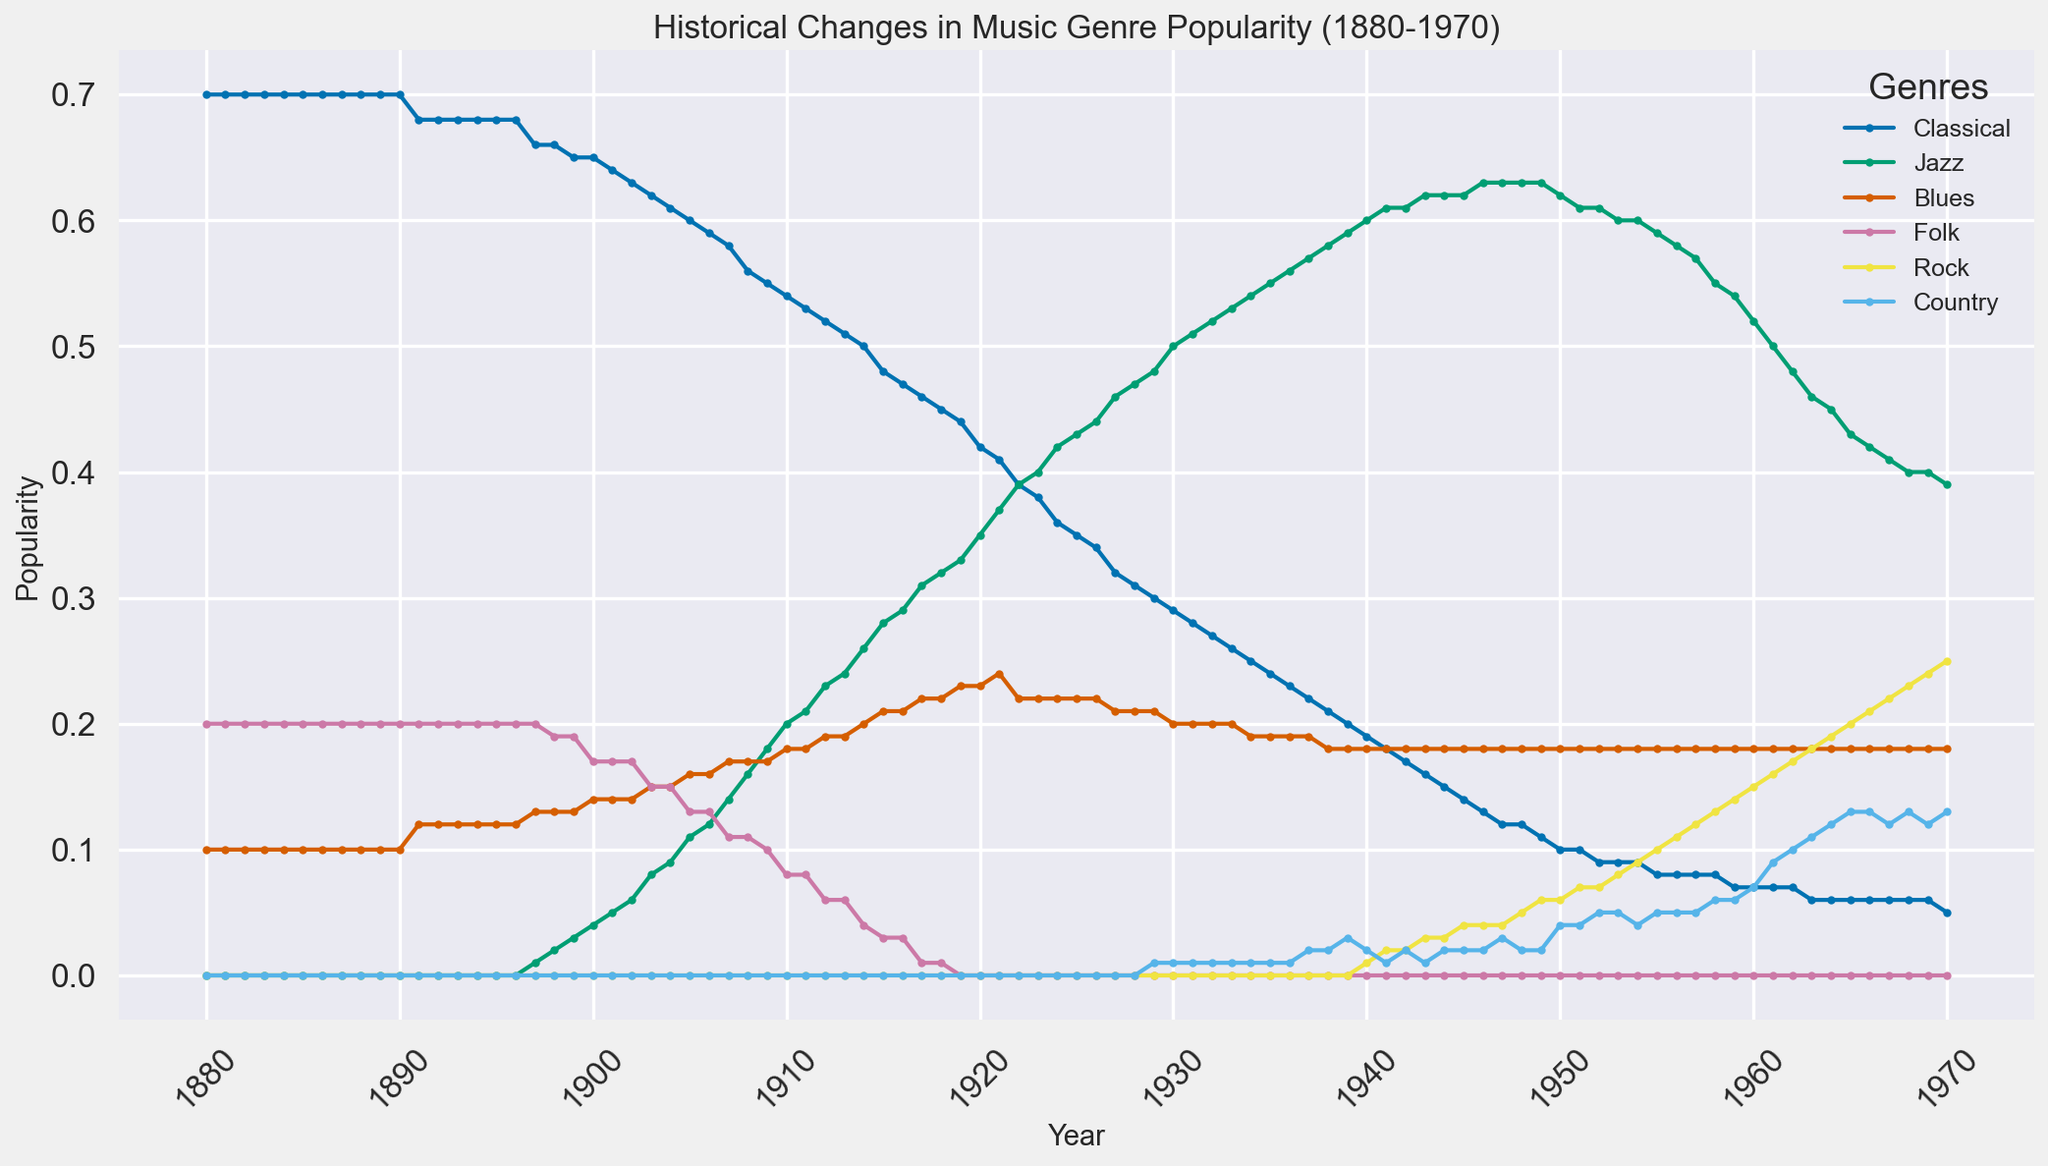What music genre was the most popular in 1883? Looking at the line chart for the year 1883, the genre with the highest popularity is Classical.
Answer: Classical In which year did Jazz surpass Blues in popularity? To determine when Jazz surpassed Blues, look for the point where the Jazz line crosses above the Blues line. This happened in 1924.
Answer: 1924 From 1950 to 1960, how did the popularity of Rock change? Observing the line representing Rock between the years 1950 and 1960, it increased from 0 to approximately 0.15.
Answer: Increased Which genre had the steepest decline in popularity from 1910 to 1930? Comparing the slopes of the lines for each genre from 1910 to 1930, Classical had the steepest decline, dropping from 0.54 to 0.29.
Answer: Classical During which decade did Country music first appear on the chart? Looking for the first appearance of the Country line, it begins in the 1930s.
Answer: 1930s At what approximate value did Folk popularity start declining? Following the chart, Folk maintained a constant value of 0.2 until around 1900 when it first dropped to 0.19.
Answer: 0.2 How does the popularity of Jazz in 1960 compare to its popularity in 1940? Comparing the heights of the Jazz line for 1960 and 1940, in 1960 it is 0.52 whereas in 1940 it was 0.60, thus it decreased.
Answer: Decreased Arrange the genres by their popularity in the year 1915 from highest to lowest. For the year 1915, the popularity values are Classical (0.48), Jazz (0.28), Blues (0.21), Folk (0.03), Rock (0.0), and Country (0.0). Arranging them yields Classical, Jazz, Blues, Folk, Rock = Country.
Answer: Classical, Jazz, Blues, Folk, Rock = Country What year did Blues reach its peak popularity? By observing the Blues line, the peak value reached was around 0.24 in 1921.
Answer: 1921 